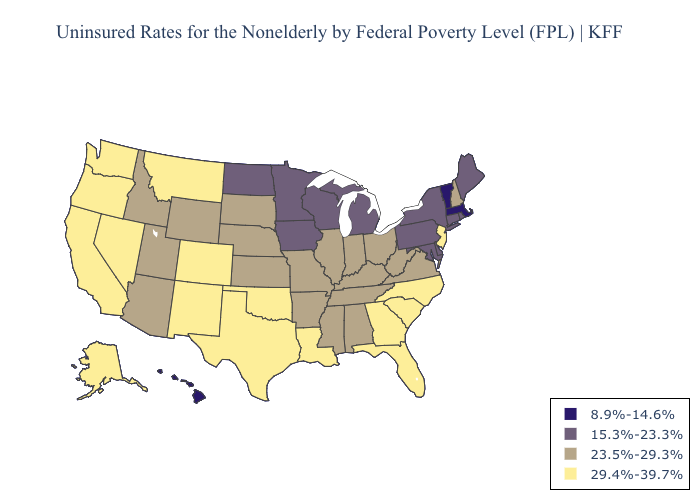What is the value of Hawaii?
Be succinct. 8.9%-14.6%. What is the lowest value in the West?
Write a very short answer. 8.9%-14.6%. Does Nebraska have a lower value than New York?
Keep it brief. No. Name the states that have a value in the range 23.5%-29.3%?
Be succinct. Alabama, Arizona, Arkansas, Idaho, Illinois, Indiana, Kansas, Kentucky, Mississippi, Missouri, Nebraska, New Hampshire, Ohio, South Dakota, Tennessee, Utah, Virginia, West Virginia, Wyoming. Among the states that border Louisiana , does Arkansas have the highest value?
Be succinct. No. What is the value of Iowa?
Keep it brief. 15.3%-23.3%. What is the value of Rhode Island?
Give a very brief answer. 15.3%-23.3%. Name the states that have a value in the range 23.5%-29.3%?
Give a very brief answer. Alabama, Arizona, Arkansas, Idaho, Illinois, Indiana, Kansas, Kentucky, Mississippi, Missouri, Nebraska, New Hampshire, Ohio, South Dakota, Tennessee, Utah, Virginia, West Virginia, Wyoming. Among the states that border Massachusetts , does Vermont have the lowest value?
Be succinct. Yes. What is the value of Minnesota?
Keep it brief. 15.3%-23.3%. What is the value of Vermont?
Quick response, please. 8.9%-14.6%. Does Pennsylvania have the highest value in the USA?
Give a very brief answer. No. What is the lowest value in the West?
Give a very brief answer. 8.9%-14.6%. How many symbols are there in the legend?
Write a very short answer. 4. 